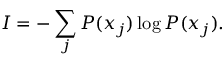Convert formula to latex. <formula><loc_0><loc_0><loc_500><loc_500>I = - \sum _ { j } P ( x _ { j } ) \log P ( x _ { j } ) .</formula> 